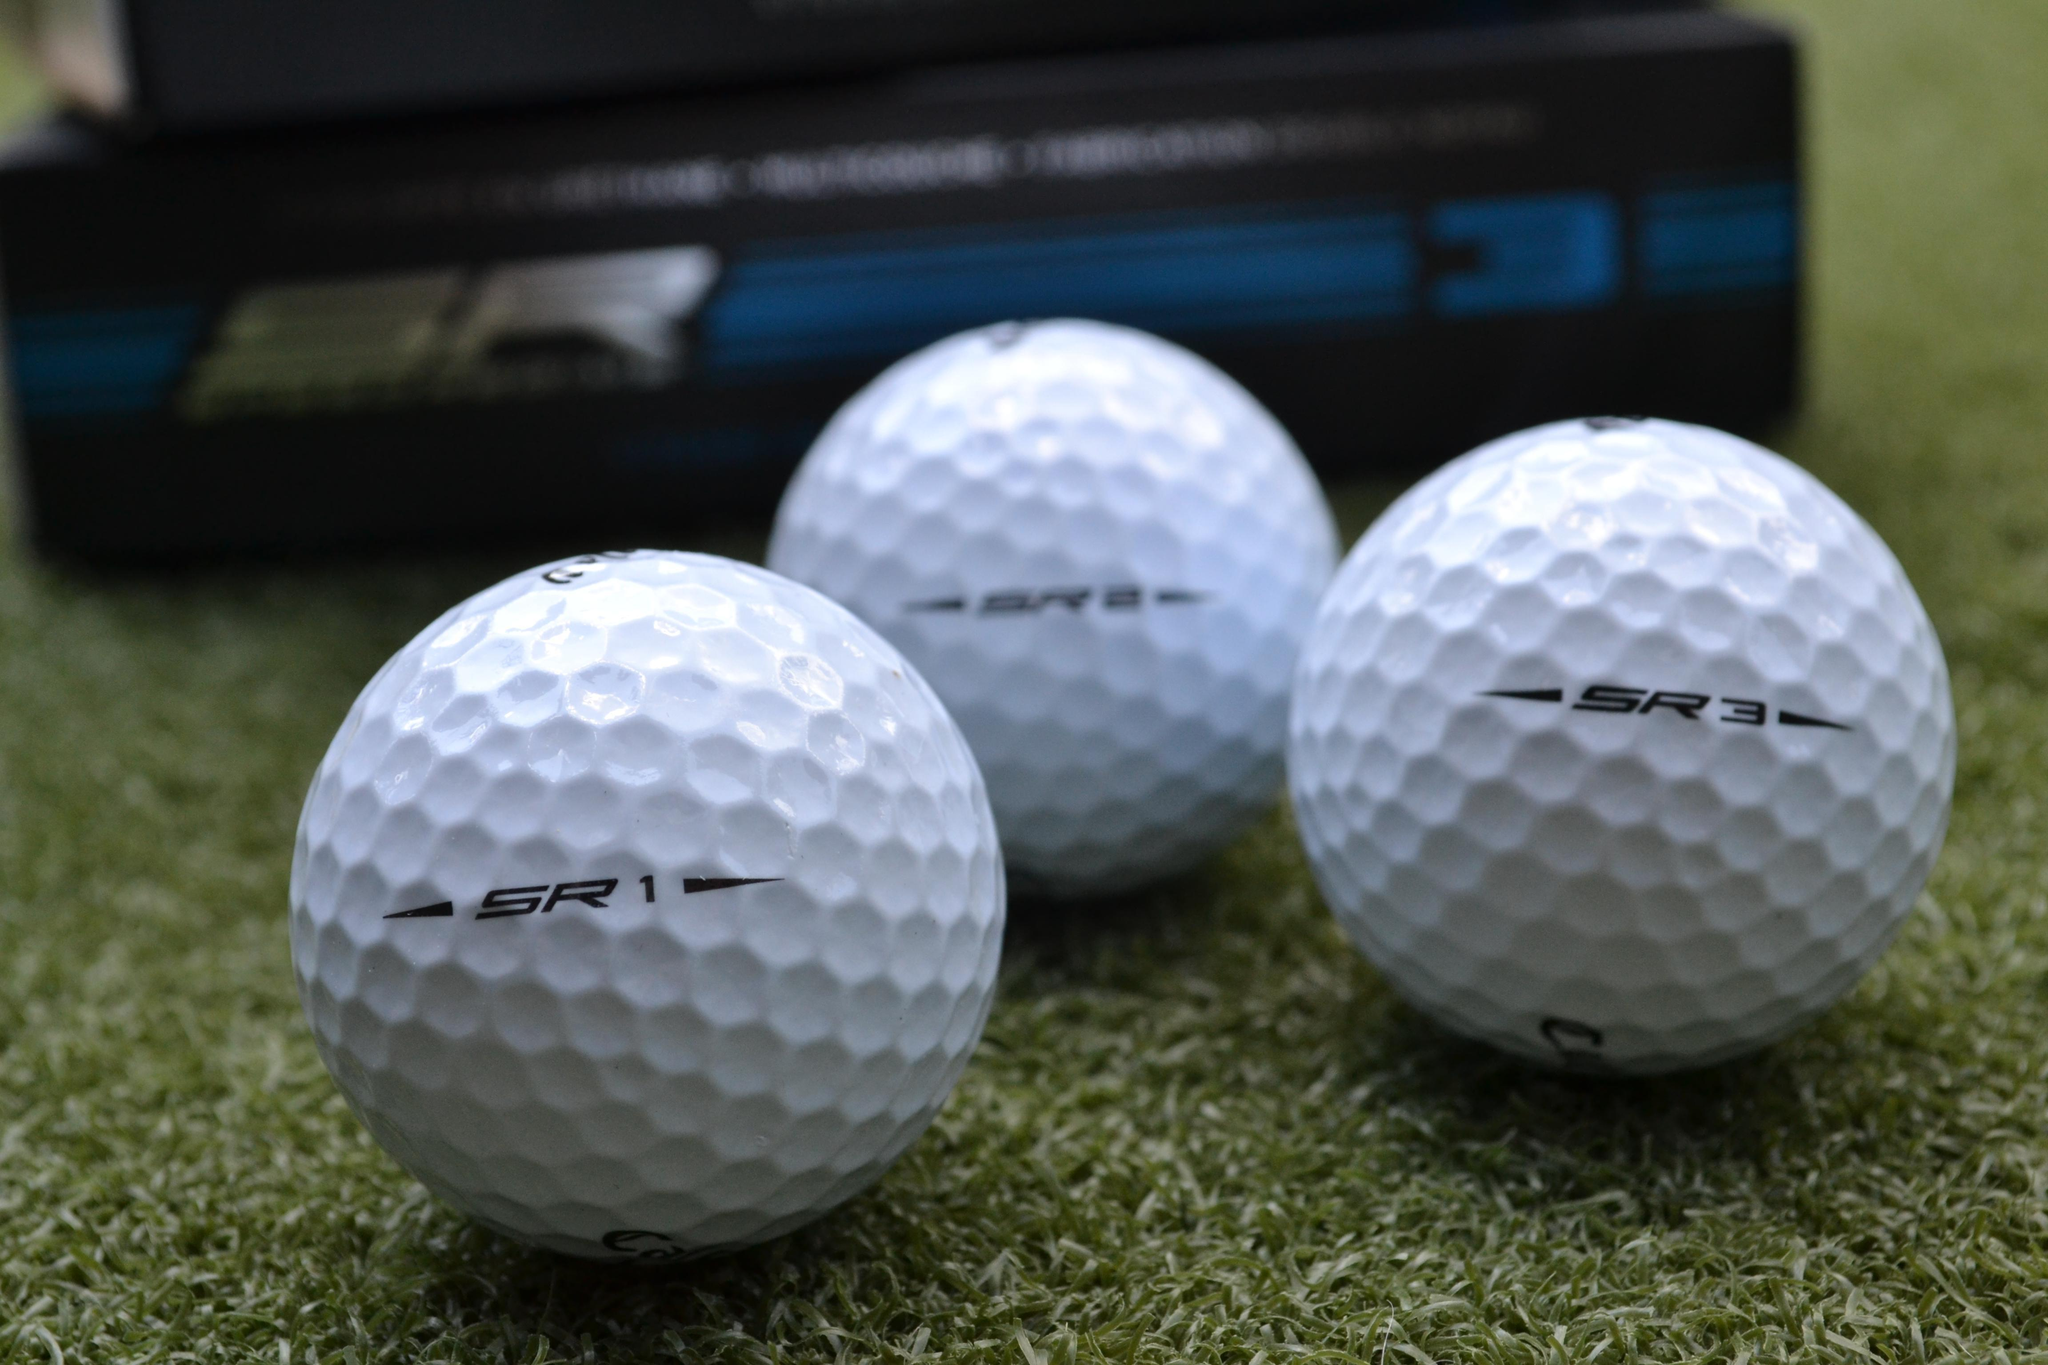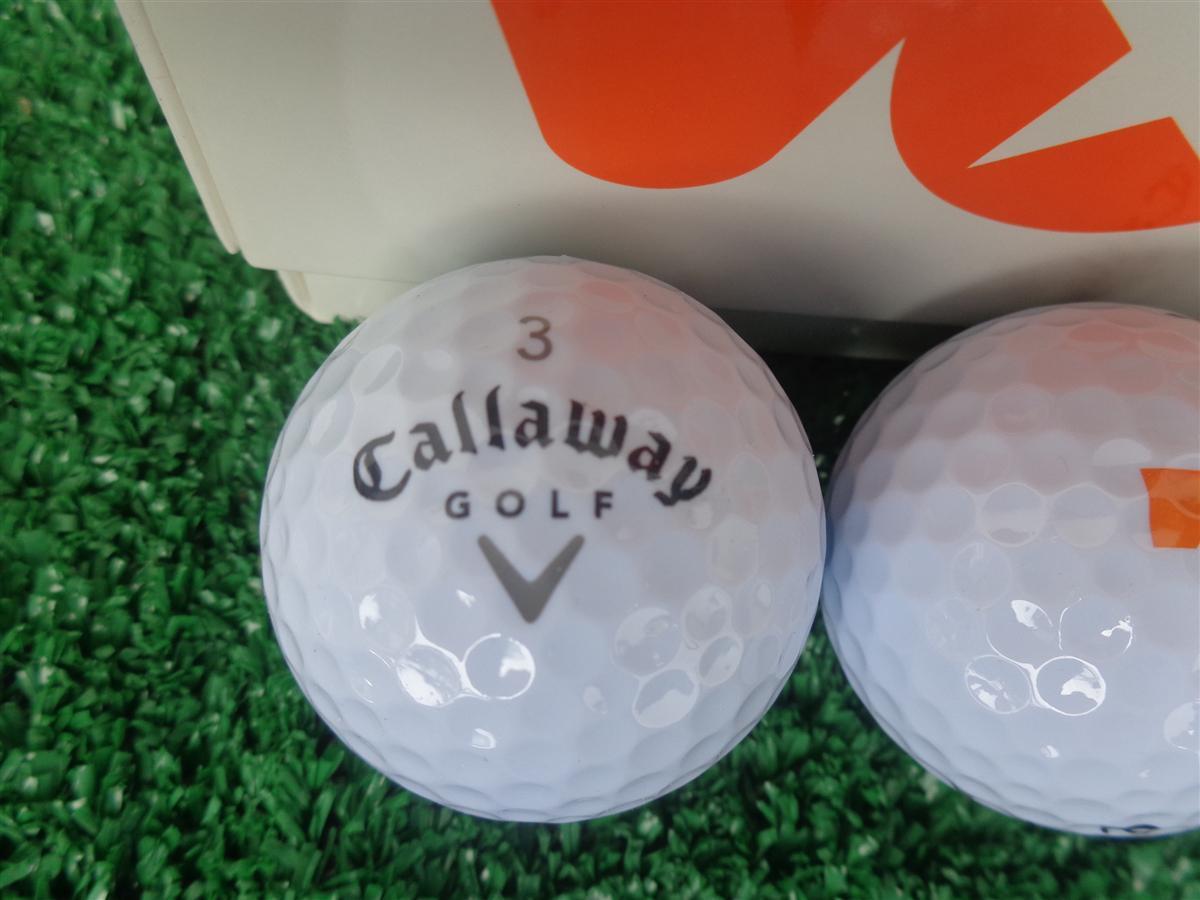The first image is the image on the left, the second image is the image on the right. For the images shown, is this caption "there are exactly three balls in one of the images." true? Answer yes or no. Yes. 